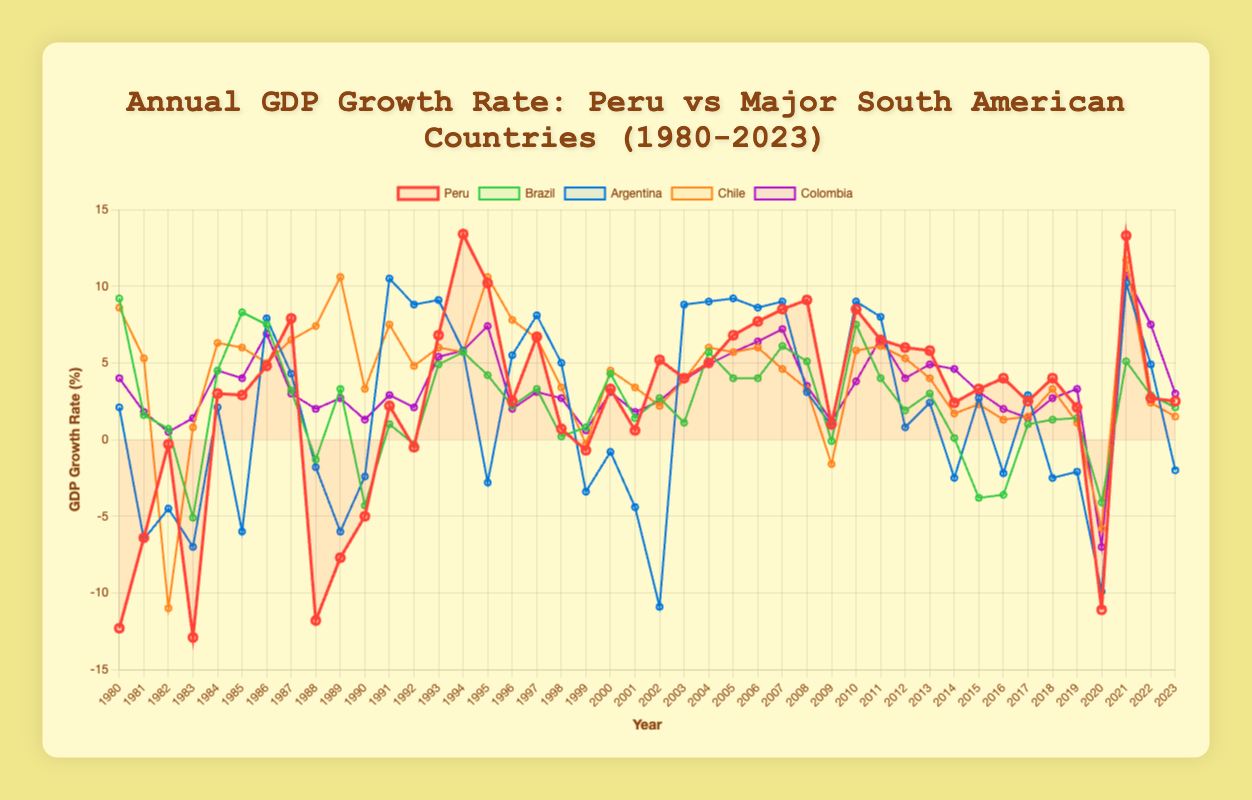What was the GDP growth rate of Peru compared to Brazil in 1980? To find the GDP growth rates for Peru and Brazil in 1980, observe the corresponding points: Peru is at -12.3% and Brazil is at 9.2%.
Answer: Peru: -12.3%, Brazil: 9.2% Which country had the lowest GDP growth rate in 1983? Look at the data points for 1983 on the graph. The country with the lowest point is Peru at -12.9%.
Answer: Peru How does Peru's GDP growth rate in 1994 compare to that of Colombia? In 1994, Peru's GDP growth rate is 13.4%, and Colombia's is 5.8%. Peru's rate is higher.
Answer: Peru's rate is higher What is the overall trend of Peru's GDP growth rate from 1980 to 2000? Observe the line for Peru between 1980 and 2000. The trend shows a lot of volatility, with significant drops initially in the 1980s, recovery in the 1990s, and some fluctuations leading up to 2000.
Answer: Volatile with recovery in the 1990s During what year did all five countries experience a negative GDP growth rate? Look for a year where all lines dip below the horizontal axis (0) simultaneously. In 2020, all countries had negative growth rates.
Answer: 2020 Which two countries had the closest GDP growth rates in 2023? Compare the data points for 2023 and find the two closest values. For 2023, Peru and Brazil have growth rates of 2.5% and 2.1%, respectively.
Answer: Peru and Brazil Calculate the average GDP growth rate for Peru during the period between 1991 and 1995. Add the growth rates from 1991 (2.2%), 1992 (-0.5%), 1993 (6.8%), 1994 (13.4%), and 1995 (10.2%), then divide by 5: (2.2 + (-0.5) + 6.8 + 13.4 + 10.2) / 5 = 6.42%
Answer: 6.42% In which year did Chile outperform all other countries in GDP growth rate? Identify the highest peak for Chile across the entire timeline. In 1989, Chile had a peak growth rate of 10.6%, outperforming all others.
Answer: 1989 Compare the GDP growth rates of Argentina and Chile in 2006. Which one was higher? Look at the points for 2006. Argentina's GDP growth is 8.6%, and Chile's is 6.0%. Argentina's rate is higher.
Answer: Argentina In which years did Peru's GDP growth rate exceed 8.0%? Identify the years where Peru's data points are above 8.0%. These years are 1994 (13.4%), 2006 (8.5%), 2007 (9.1%), and 2021 (13.3%).
Answer: 1994, 2006, 2007, 2021 